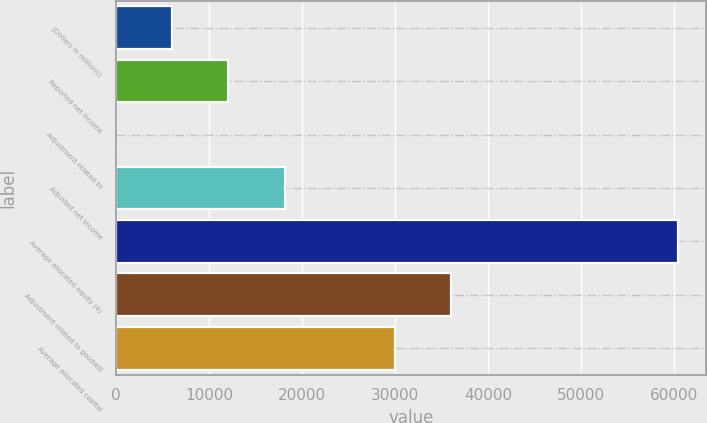Convert chart. <chart><loc_0><loc_0><loc_500><loc_500><bar_chart><fcel>(Dollars in millions)<fcel>Reported net income<fcel>Adjustment related to<fcel>Adjusted net income<fcel>Average allocated equity (4)<fcel>Adjustment related to goodwill<fcel>Average allocated capital<nl><fcel>6043.4<fcel>12082.8<fcel>4<fcel>18122.2<fcel>60398<fcel>36039.4<fcel>30000<nl></chart> 